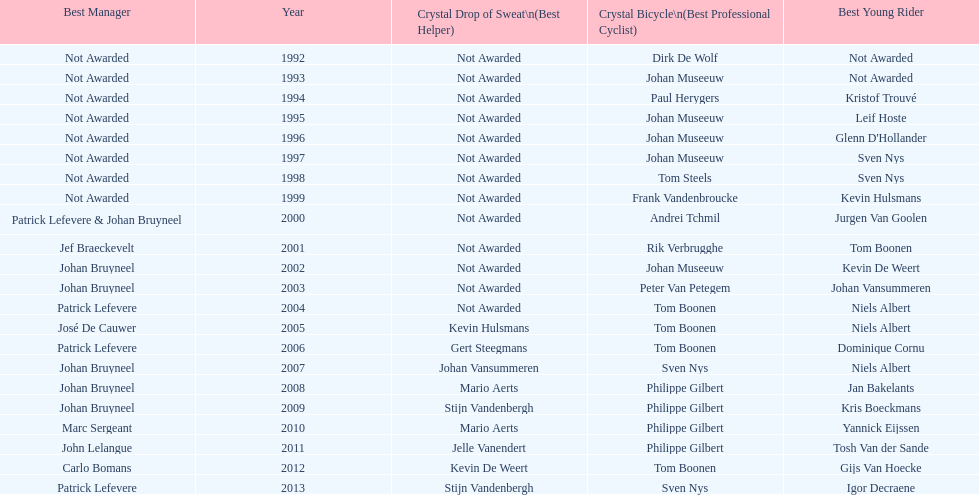Who has won the most best young rider awards? Niels Albert. 